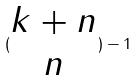Convert formula to latex. <formula><loc_0><loc_0><loc_500><loc_500>( \begin{matrix} k + n \\ n \end{matrix} ) - 1</formula> 